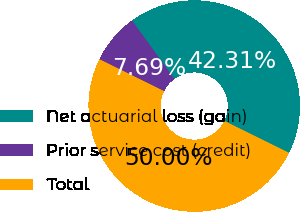Convert chart to OTSL. <chart><loc_0><loc_0><loc_500><loc_500><pie_chart><fcel>Net actuarial loss (gain)<fcel>Prior service cost (credit)<fcel>Total<nl><fcel>42.31%<fcel>7.69%<fcel>50.0%<nl></chart> 